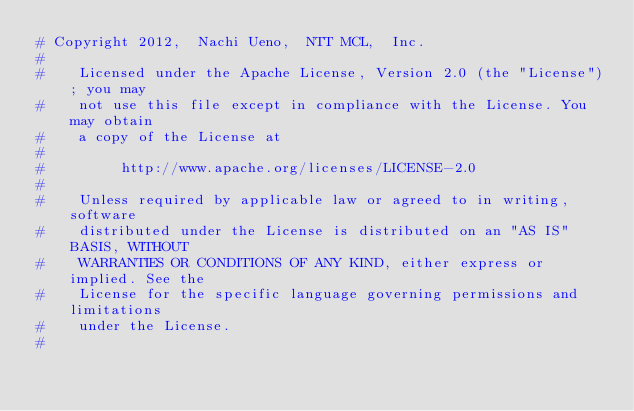Convert code to text. <code><loc_0><loc_0><loc_500><loc_500><_Python_># Copyright 2012,  Nachi Ueno,  NTT MCL,  Inc.
#
#    Licensed under the Apache License, Version 2.0 (the "License"); you may
#    not use this file except in compliance with the License. You may obtain
#    a copy of the License at
#
#         http://www.apache.org/licenses/LICENSE-2.0
#
#    Unless required by applicable law or agreed to in writing, software
#    distributed under the License is distributed on an "AS IS" BASIS, WITHOUT
#    WARRANTIES OR CONDITIONS OF ANY KIND, either express or implied. See the
#    License for the specific language governing permissions and limitations
#    under the License.
#</code> 